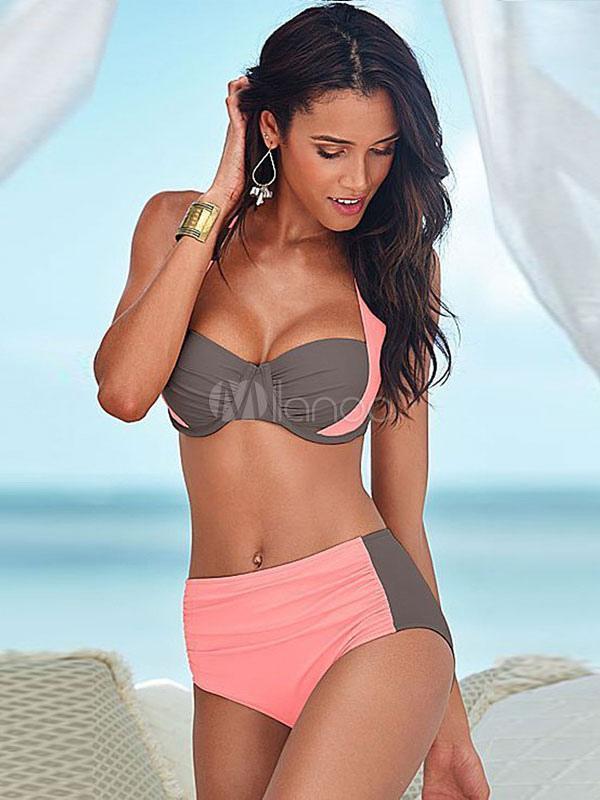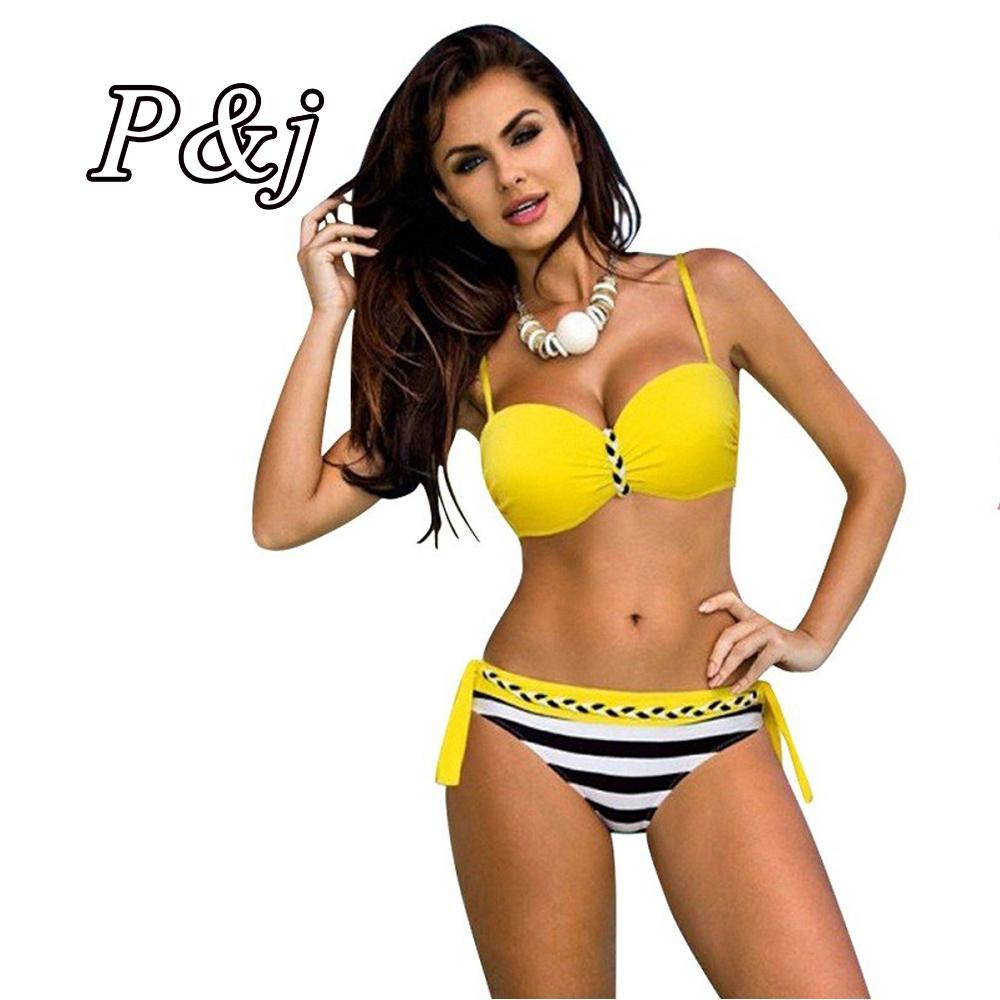The first image is the image on the left, the second image is the image on the right. Analyze the images presented: Is the assertion "All models wear bikinis with matching color tops and bottoms." valid? Answer yes or no. No. The first image is the image on the left, the second image is the image on the right. For the images shown, is this caption "At least part of at least one of the woman's swimwear is black." true? Answer yes or no. No. 